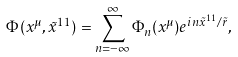Convert formula to latex. <formula><loc_0><loc_0><loc_500><loc_500>\Phi ( x ^ { \mu } , { \tilde { x } } ^ { 1 1 } ) = \sum _ { n = - \infty } ^ { \infty } \Phi _ { n } ( x ^ { \mu } ) e ^ { i n { \tilde { x } } ^ { 1 1 } / { \tilde { r } } } ,</formula> 